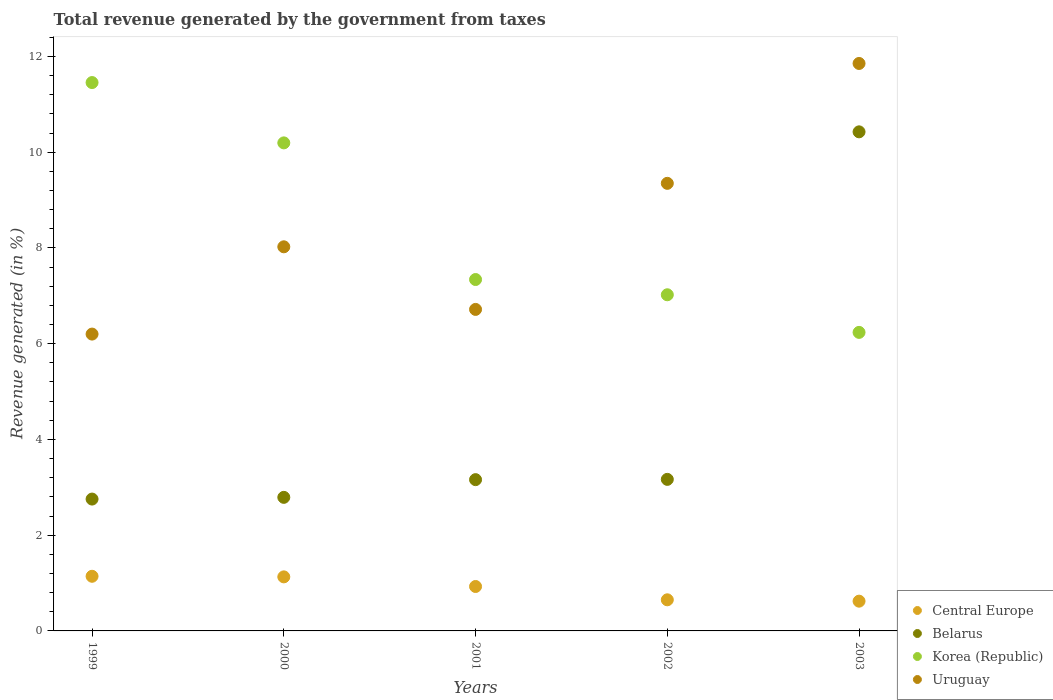How many different coloured dotlines are there?
Offer a terse response. 4. Is the number of dotlines equal to the number of legend labels?
Keep it short and to the point. Yes. What is the total revenue generated in Belarus in 2001?
Offer a terse response. 3.16. Across all years, what is the maximum total revenue generated in Korea (Republic)?
Keep it short and to the point. 11.46. Across all years, what is the minimum total revenue generated in Belarus?
Give a very brief answer. 2.75. In which year was the total revenue generated in Belarus minimum?
Provide a short and direct response. 1999. What is the total total revenue generated in Uruguay in the graph?
Make the answer very short. 42.15. What is the difference between the total revenue generated in Korea (Republic) in 2002 and that in 2003?
Your answer should be very brief. 0.79. What is the difference between the total revenue generated in Belarus in 1999 and the total revenue generated in Central Europe in 2000?
Offer a terse response. 1.63. What is the average total revenue generated in Uruguay per year?
Your answer should be very brief. 8.43. In the year 1999, what is the difference between the total revenue generated in Korea (Republic) and total revenue generated in Central Europe?
Your response must be concise. 10.31. In how many years, is the total revenue generated in Belarus greater than 4 %?
Offer a terse response. 1. What is the ratio of the total revenue generated in Central Europe in 2000 to that in 2002?
Your response must be concise. 1.74. Is the total revenue generated in Uruguay in 2000 less than that in 2001?
Keep it short and to the point. No. Is the difference between the total revenue generated in Korea (Republic) in 2001 and 2002 greater than the difference between the total revenue generated in Central Europe in 2001 and 2002?
Ensure brevity in your answer.  Yes. What is the difference between the highest and the second highest total revenue generated in Korea (Republic)?
Ensure brevity in your answer.  1.26. What is the difference between the highest and the lowest total revenue generated in Korea (Republic)?
Your answer should be very brief. 5.22. In how many years, is the total revenue generated in Belarus greater than the average total revenue generated in Belarus taken over all years?
Offer a terse response. 1. Is it the case that in every year, the sum of the total revenue generated in Central Europe and total revenue generated in Uruguay  is greater than the sum of total revenue generated in Korea (Republic) and total revenue generated in Belarus?
Your answer should be compact. Yes. Is the total revenue generated in Korea (Republic) strictly greater than the total revenue generated in Uruguay over the years?
Your answer should be very brief. No. How many dotlines are there?
Keep it short and to the point. 4. How many years are there in the graph?
Give a very brief answer. 5. What is the difference between two consecutive major ticks on the Y-axis?
Your answer should be very brief. 2. Does the graph contain any zero values?
Offer a terse response. No. How many legend labels are there?
Your answer should be compact. 4. How are the legend labels stacked?
Provide a short and direct response. Vertical. What is the title of the graph?
Your answer should be compact. Total revenue generated by the government from taxes. Does "St. Vincent and the Grenadines" appear as one of the legend labels in the graph?
Give a very brief answer. No. What is the label or title of the X-axis?
Ensure brevity in your answer.  Years. What is the label or title of the Y-axis?
Provide a short and direct response. Revenue generated (in %). What is the Revenue generated (in %) in Central Europe in 1999?
Give a very brief answer. 1.14. What is the Revenue generated (in %) of Belarus in 1999?
Your answer should be compact. 2.75. What is the Revenue generated (in %) in Korea (Republic) in 1999?
Provide a short and direct response. 11.46. What is the Revenue generated (in %) in Uruguay in 1999?
Make the answer very short. 6.2. What is the Revenue generated (in %) of Central Europe in 2000?
Make the answer very short. 1.13. What is the Revenue generated (in %) of Belarus in 2000?
Offer a very short reply. 2.79. What is the Revenue generated (in %) of Korea (Republic) in 2000?
Provide a succinct answer. 10.2. What is the Revenue generated (in %) in Uruguay in 2000?
Provide a succinct answer. 8.02. What is the Revenue generated (in %) of Central Europe in 2001?
Offer a terse response. 0.93. What is the Revenue generated (in %) of Belarus in 2001?
Ensure brevity in your answer.  3.16. What is the Revenue generated (in %) of Korea (Republic) in 2001?
Keep it short and to the point. 7.34. What is the Revenue generated (in %) of Uruguay in 2001?
Provide a succinct answer. 6.72. What is the Revenue generated (in %) of Central Europe in 2002?
Offer a very short reply. 0.65. What is the Revenue generated (in %) in Belarus in 2002?
Your answer should be compact. 3.17. What is the Revenue generated (in %) of Korea (Republic) in 2002?
Provide a short and direct response. 7.02. What is the Revenue generated (in %) in Uruguay in 2002?
Offer a very short reply. 9.35. What is the Revenue generated (in %) of Central Europe in 2003?
Offer a very short reply. 0.62. What is the Revenue generated (in %) in Belarus in 2003?
Your answer should be compact. 10.43. What is the Revenue generated (in %) in Korea (Republic) in 2003?
Offer a terse response. 6.24. What is the Revenue generated (in %) of Uruguay in 2003?
Make the answer very short. 11.85. Across all years, what is the maximum Revenue generated (in %) of Central Europe?
Your answer should be compact. 1.14. Across all years, what is the maximum Revenue generated (in %) of Belarus?
Your answer should be compact. 10.43. Across all years, what is the maximum Revenue generated (in %) in Korea (Republic)?
Keep it short and to the point. 11.46. Across all years, what is the maximum Revenue generated (in %) in Uruguay?
Your answer should be very brief. 11.85. Across all years, what is the minimum Revenue generated (in %) of Central Europe?
Make the answer very short. 0.62. Across all years, what is the minimum Revenue generated (in %) of Belarus?
Offer a very short reply. 2.75. Across all years, what is the minimum Revenue generated (in %) of Korea (Republic)?
Offer a very short reply. 6.24. Across all years, what is the minimum Revenue generated (in %) of Uruguay?
Provide a succinct answer. 6.2. What is the total Revenue generated (in %) in Central Europe in the graph?
Keep it short and to the point. 4.47. What is the total Revenue generated (in %) in Belarus in the graph?
Your answer should be very brief. 22.3. What is the total Revenue generated (in %) in Korea (Republic) in the graph?
Your response must be concise. 42.25. What is the total Revenue generated (in %) in Uruguay in the graph?
Offer a terse response. 42.15. What is the difference between the Revenue generated (in %) in Central Europe in 1999 and that in 2000?
Your answer should be compact. 0.01. What is the difference between the Revenue generated (in %) in Belarus in 1999 and that in 2000?
Offer a very short reply. -0.04. What is the difference between the Revenue generated (in %) of Korea (Republic) in 1999 and that in 2000?
Keep it short and to the point. 1.26. What is the difference between the Revenue generated (in %) of Uruguay in 1999 and that in 2000?
Offer a terse response. -1.82. What is the difference between the Revenue generated (in %) in Central Europe in 1999 and that in 2001?
Keep it short and to the point. 0.21. What is the difference between the Revenue generated (in %) in Belarus in 1999 and that in 2001?
Provide a succinct answer. -0.41. What is the difference between the Revenue generated (in %) in Korea (Republic) in 1999 and that in 2001?
Provide a succinct answer. 4.11. What is the difference between the Revenue generated (in %) of Uruguay in 1999 and that in 2001?
Offer a very short reply. -0.52. What is the difference between the Revenue generated (in %) in Central Europe in 1999 and that in 2002?
Ensure brevity in your answer.  0.49. What is the difference between the Revenue generated (in %) of Belarus in 1999 and that in 2002?
Give a very brief answer. -0.41. What is the difference between the Revenue generated (in %) of Korea (Republic) in 1999 and that in 2002?
Keep it short and to the point. 4.43. What is the difference between the Revenue generated (in %) of Uruguay in 1999 and that in 2002?
Keep it short and to the point. -3.15. What is the difference between the Revenue generated (in %) in Central Europe in 1999 and that in 2003?
Make the answer very short. 0.52. What is the difference between the Revenue generated (in %) of Belarus in 1999 and that in 2003?
Give a very brief answer. -7.67. What is the difference between the Revenue generated (in %) in Korea (Republic) in 1999 and that in 2003?
Provide a short and direct response. 5.22. What is the difference between the Revenue generated (in %) in Uruguay in 1999 and that in 2003?
Your answer should be compact. -5.65. What is the difference between the Revenue generated (in %) of Central Europe in 2000 and that in 2001?
Your answer should be compact. 0.2. What is the difference between the Revenue generated (in %) of Belarus in 2000 and that in 2001?
Provide a short and direct response. -0.37. What is the difference between the Revenue generated (in %) of Korea (Republic) in 2000 and that in 2001?
Ensure brevity in your answer.  2.85. What is the difference between the Revenue generated (in %) of Uruguay in 2000 and that in 2001?
Your response must be concise. 1.31. What is the difference between the Revenue generated (in %) in Central Europe in 2000 and that in 2002?
Ensure brevity in your answer.  0.48. What is the difference between the Revenue generated (in %) in Belarus in 2000 and that in 2002?
Ensure brevity in your answer.  -0.38. What is the difference between the Revenue generated (in %) in Korea (Republic) in 2000 and that in 2002?
Offer a terse response. 3.17. What is the difference between the Revenue generated (in %) of Uruguay in 2000 and that in 2002?
Provide a succinct answer. -1.33. What is the difference between the Revenue generated (in %) of Central Europe in 2000 and that in 2003?
Offer a very short reply. 0.51. What is the difference between the Revenue generated (in %) in Belarus in 2000 and that in 2003?
Your answer should be very brief. -7.64. What is the difference between the Revenue generated (in %) in Korea (Republic) in 2000 and that in 2003?
Your answer should be very brief. 3.96. What is the difference between the Revenue generated (in %) in Uruguay in 2000 and that in 2003?
Offer a terse response. -3.83. What is the difference between the Revenue generated (in %) in Central Europe in 2001 and that in 2002?
Your response must be concise. 0.28. What is the difference between the Revenue generated (in %) in Belarus in 2001 and that in 2002?
Keep it short and to the point. -0.01. What is the difference between the Revenue generated (in %) in Korea (Republic) in 2001 and that in 2002?
Keep it short and to the point. 0.32. What is the difference between the Revenue generated (in %) in Uruguay in 2001 and that in 2002?
Make the answer very short. -2.63. What is the difference between the Revenue generated (in %) in Central Europe in 2001 and that in 2003?
Ensure brevity in your answer.  0.31. What is the difference between the Revenue generated (in %) of Belarus in 2001 and that in 2003?
Your answer should be very brief. -7.27. What is the difference between the Revenue generated (in %) of Korea (Republic) in 2001 and that in 2003?
Keep it short and to the point. 1.1. What is the difference between the Revenue generated (in %) in Uruguay in 2001 and that in 2003?
Your response must be concise. -5.14. What is the difference between the Revenue generated (in %) of Central Europe in 2002 and that in 2003?
Offer a very short reply. 0.03. What is the difference between the Revenue generated (in %) of Belarus in 2002 and that in 2003?
Your answer should be compact. -7.26. What is the difference between the Revenue generated (in %) of Korea (Republic) in 2002 and that in 2003?
Offer a terse response. 0.79. What is the difference between the Revenue generated (in %) in Uruguay in 2002 and that in 2003?
Provide a short and direct response. -2.5. What is the difference between the Revenue generated (in %) in Central Europe in 1999 and the Revenue generated (in %) in Belarus in 2000?
Make the answer very short. -1.65. What is the difference between the Revenue generated (in %) in Central Europe in 1999 and the Revenue generated (in %) in Korea (Republic) in 2000?
Your response must be concise. -9.05. What is the difference between the Revenue generated (in %) in Central Europe in 1999 and the Revenue generated (in %) in Uruguay in 2000?
Provide a short and direct response. -6.88. What is the difference between the Revenue generated (in %) in Belarus in 1999 and the Revenue generated (in %) in Korea (Republic) in 2000?
Provide a short and direct response. -7.44. What is the difference between the Revenue generated (in %) of Belarus in 1999 and the Revenue generated (in %) of Uruguay in 2000?
Your response must be concise. -5.27. What is the difference between the Revenue generated (in %) in Korea (Republic) in 1999 and the Revenue generated (in %) in Uruguay in 2000?
Make the answer very short. 3.43. What is the difference between the Revenue generated (in %) in Central Europe in 1999 and the Revenue generated (in %) in Belarus in 2001?
Provide a short and direct response. -2.02. What is the difference between the Revenue generated (in %) in Central Europe in 1999 and the Revenue generated (in %) in Korea (Republic) in 2001?
Give a very brief answer. -6.2. What is the difference between the Revenue generated (in %) in Central Europe in 1999 and the Revenue generated (in %) in Uruguay in 2001?
Offer a very short reply. -5.57. What is the difference between the Revenue generated (in %) in Belarus in 1999 and the Revenue generated (in %) in Korea (Republic) in 2001?
Provide a succinct answer. -4.59. What is the difference between the Revenue generated (in %) of Belarus in 1999 and the Revenue generated (in %) of Uruguay in 2001?
Keep it short and to the point. -3.96. What is the difference between the Revenue generated (in %) of Korea (Republic) in 1999 and the Revenue generated (in %) of Uruguay in 2001?
Provide a short and direct response. 4.74. What is the difference between the Revenue generated (in %) of Central Europe in 1999 and the Revenue generated (in %) of Belarus in 2002?
Your answer should be very brief. -2.02. What is the difference between the Revenue generated (in %) in Central Europe in 1999 and the Revenue generated (in %) in Korea (Republic) in 2002?
Ensure brevity in your answer.  -5.88. What is the difference between the Revenue generated (in %) of Central Europe in 1999 and the Revenue generated (in %) of Uruguay in 2002?
Ensure brevity in your answer.  -8.21. What is the difference between the Revenue generated (in %) of Belarus in 1999 and the Revenue generated (in %) of Korea (Republic) in 2002?
Keep it short and to the point. -4.27. What is the difference between the Revenue generated (in %) in Belarus in 1999 and the Revenue generated (in %) in Uruguay in 2002?
Keep it short and to the point. -6.6. What is the difference between the Revenue generated (in %) in Korea (Republic) in 1999 and the Revenue generated (in %) in Uruguay in 2002?
Your answer should be compact. 2.11. What is the difference between the Revenue generated (in %) in Central Europe in 1999 and the Revenue generated (in %) in Belarus in 2003?
Ensure brevity in your answer.  -9.28. What is the difference between the Revenue generated (in %) in Central Europe in 1999 and the Revenue generated (in %) in Korea (Republic) in 2003?
Give a very brief answer. -5.09. What is the difference between the Revenue generated (in %) of Central Europe in 1999 and the Revenue generated (in %) of Uruguay in 2003?
Ensure brevity in your answer.  -10.71. What is the difference between the Revenue generated (in %) in Belarus in 1999 and the Revenue generated (in %) in Korea (Republic) in 2003?
Offer a very short reply. -3.48. What is the difference between the Revenue generated (in %) of Belarus in 1999 and the Revenue generated (in %) of Uruguay in 2003?
Your answer should be very brief. -9.1. What is the difference between the Revenue generated (in %) of Korea (Republic) in 1999 and the Revenue generated (in %) of Uruguay in 2003?
Offer a very short reply. -0.4. What is the difference between the Revenue generated (in %) of Central Europe in 2000 and the Revenue generated (in %) of Belarus in 2001?
Offer a terse response. -2.03. What is the difference between the Revenue generated (in %) of Central Europe in 2000 and the Revenue generated (in %) of Korea (Republic) in 2001?
Make the answer very short. -6.21. What is the difference between the Revenue generated (in %) in Central Europe in 2000 and the Revenue generated (in %) in Uruguay in 2001?
Your answer should be compact. -5.59. What is the difference between the Revenue generated (in %) in Belarus in 2000 and the Revenue generated (in %) in Korea (Republic) in 2001?
Provide a short and direct response. -4.55. What is the difference between the Revenue generated (in %) of Belarus in 2000 and the Revenue generated (in %) of Uruguay in 2001?
Your answer should be compact. -3.93. What is the difference between the Revenue generated (in %) of Korea (Republic) in 2000 and the Revenue generated (in %) of Uruguay in 2001?
Your response must be concise. 3.48. What is the difference between the Revenue generated (in %) in Central Europe in 2000 and the Revenue generated (in %) in Belarus in 2002?
Offer a terse response. -2.04. What is the difference between the Revenue generated (in %) of Central Europe in 2000 and the Revenue generated (in %) of Korea (Republic) in 2002?
Provide a short and direct response. -5.89. What is the difference between the Revenue generated (in %) of Central Europe in 2000 and the Revenue generated (in %) of Uruguay in 2002?
Give a very brief answer. -8.22. What is the difference between the Revenue generated (in %) of Belarus in 2000 and the Revenue generated (in %) of Korea (Republic) in 2002?
Offer a terse response. -4.23. What is the difference between the Revenue generated (in %) in Belarus in 2000 and the Revenue generated (in %) in Uruguay in 2002?
Ensure brevity in your answer.  -6.56. What is the difference between the Revenue generated (in %) in Korea (Republic) in 2000 and the Revenue generated (in %) in Uruguay in 2002?
Offer a terse response. 0.85. What is the difference between the Revenue generated (in %) of Central Europe in 2000 and the Revenue generated (in %) of Belarus in 2003?
Make the answer very short. -9.3. What is the difference between the Revenue generated (in %) of Central Europe in 2000 and the Revenue generated (in %) of Korea (Republic) in 2003?
Your response must be concise. -5.11. What is the difference between the Revenue generated (in %) of Central Europe in 2000 and the Revenue generated (in %) of Uruguay in 2003?
Make the answer very short. -10.73. What is the difference between the Revenue generated (in %) of Belarus in 2000 and the Revenue generated (in %) of Korea (Republic) in 2003?
Offer a terse response. -3.45. What is the difference between the Revenue generated (in %) in Belarus in 2000 and the Revenue generated (in %) in Uruguay in 2003?
Your answer should be compact. -9.06. What is the difference between the Revenue generated (in %) of Korea (Republic) in 2000 and the Revenue generated (in %) of Uruguay in 2003?
Your answer should be very brief. -1.66. What is the difference between the Revenue generated (in %) of Central Europe in 2001 and the Revenue generated (in %) of Belarus in 2002?
Give a very brief answer. -2.24. What is the difference between the Revenue generated (in %) in Central Europe in 2001 and the Revenue generated (in %) in Korea (Republic) in 2002?
Give a very brief answer. -6.09. What is the difference between the Revenue generated (in %) in Central Europe in 2001 and the Revenue generated (in %) in Uruguay in 2002?
Your response must be concise. -8.42. What is the difference between the Revenue generated (in %) in Belarus in 2001 and the Revenue generated (in %) in Korea (Republic) in 2002?
Provide a short and direct response. -3.86. What is the difference between the Revenue generated (in %) of Belarus in 2001 and the Revenue generated (in %) of Uruguay in 2002?
Offer a very short reply. -6.19. What is the difference between the Revenue generated (in %) of Korea (Republic) in 2001 and the Revenue generated (in %) of Uruguay in 2002?
Make the answer very short. -2.01. What is the difference between the Revenue generated (in %) in Central Europe in 2001 and the Revenue generated (in %) in Belarus in 2003?
Offer a very short reply. -9.5. What is the difference between the Revenue generated (in %) of Central Europe in 2001 and the Revenue generated (in %) of Korea (Republic) in 2003?
Your response must be concise. -5.31. What is the difference between the Revenue generated (in %) of Central Europe in 2001 and the Revenue generated (in %) of Uruguay in 2003?
Provide a short and direct response. -10.93. What is the difference between the Revenue generated (in %) in Belarus in 2001 and the Revenue generated (in %) in Korea (Republic) in 2003?
Your response must be concise. -3.08. What is the difference between the Revenue generated (in %) in Belarus in 2001 and the Revenue generated (in %) in Uruguay in 2003?
Make the answer very short. -8.69. What is the difference between the Revenue generated (in %) of Korea (Republic) in 2001 and the Revenue generated (in %) of Uruguay in 2003?
Provide a short and direct response. -4.51. What is the difference between the Revenue generated (in %) in Central Europe in 2002 and the Revenue generated (in %) in Belarus in 2003?
Your answer should be compact. -9.78. What is the difference between the Revenue generated (in %) in Central Europe in 2002 and the Revenue generated (in %) in Korea (Republic) in 2003?
Provide a short and direct response. -5.59. What is the difference between the Revenue generated (in %) in Central Europe in 2002 and the Revenue generated (in %) in Uruguay in 2003?
Provide a succinct answer. -11.2. What is the difference between the Revenue generated (in %) of Belarus in 2002 and the Revenue generated (in %) of Korea (Republic) in 2003?
Keep it short and to the point. -3.07. What is the difference between the Revenue generated (in %) in Belarus in 2002 and the Revenue generated (in %) in Uruguay in 2003?
Offer a very short reply. -8.69. What is the difference between the Revenue generated (in %) of Korea (Republic) in 2002 and the Revenue generated (in %) of Uruguay in 2003?
Give a very brief answer. -4.83. What is the average Revenue generated (in %) of Central Europe per year?
Offer a very short reply. 0.89. What is the average Revenue generated (in %) of Belarus per year?
Give a very brief answer. 4.46. What is the average Revenue generated (in %) in Korea (Republic) per year?
Give a very brief answer. 8.45. What is the average Revenue generated (in %) of Uruguay per year?
Offer a terse response. 8.43. In the year 1999, what is the difference between the Revenue generated (in %) of Central Europe and Revenue generated (in %) of Belarus?
Give a very brief answer. -1.61. In the year 1999, what is the difference between the Revenue generated (in %) in Central Europe and Revenue generated (in %) in Korea (Republic)?
Keep it short and to the point. -10.31. In the year 1999, what is the difference between the Revenue generated (in %) of Central Europe and Revenue generated (in %) of Uruguay?
Provide a succinct answer. -5.06. In the year 1999, what is the difference between the Revenue generated (in %) of Belarus and Revenue generated (in %) of Korea (Republic)?
Make the answer very short. -8.7. In the year 1999, what is the difference between the Revenue generated (in %) in Belarus and Revenue generated (in %) in Uruguay?
Make the answer very short. -3.45. In the year 1999, what is the difference between the Revenue generated (in %) in Korea (Republic) and Revenue generated (in %) in Uruguay?
Your response must be concise. 5.25. In the year 2000, what is the difference between the Revenue generated (in %) of Central Europe and Revenue generated (in %) of Belarus?
Keep it short and to the point. -1.66. In the year 2000, what is the difference between the Revenue generated (in %) of Central Europe and Revenue generated (in %) of Korea (Republic)?
Keep it short and to the point. -9.07. In the year 2000, what is the difference between the Revenue generated (in %) in Central Europe and Revenue generated (in %) in Uruguay?
Offer a very short reply. -6.9. In the year 2000, what is the difference between the Revenue generated (in %) of Belarus and Revenue generated (in %) of Korea (Republic)?
Provide a succinct answer. -7.4. In the year 2000, what is the difference between the Revenue generated (in %) in Belarus and Revenue generated (in %) in Uruguay?
Give a very brief answer. -5.23. In the year 2000, what is the difference between the Revenue generated (in %) in Korea (Republic) and Revenue generated (in %) in Uruguay?
Offer a very short reply. 2.17. In the year 2001, what is the difference between the Revenue generated (in %) of Central Europe and Revenue generated (in %) of Belarus?
Provide a succinct answer. -2.23. In the year 2001, what is the difference between the Revenue generated (in %) of Central Europe and Revenue generated (in %) of Korea (Republic)?
Offer a terse response. -6.41. In the year 2001, what is the difference between the Revenue generated (in %) in Central Europe and Revenue generated (in %) in Uruguay?
Provide a succinct answer. -5.79. In the year 2001, what is the difference between the Revenue generated (in %) of Belarus and Revenue generated (in %) of Korea (Republic)?
Your answer should be very brief. -4.18. In the year 2001, what is the difference between the Revenue generated (in %) in Belarus and Revenue generated (in %) in Uruguay?
Offer a terse response. -3.56. In the year 2001, what is the difference between the Revenue generated (in %) of Korea (Republic) and Revenue generated (in %) of Uruguay?
Ensure brevity in your answer.  0.62. In the year 2002, what is the difference between the Revenue generated (in %) in Central Europe and Revenue generated (in %) in Belarus?
Offer a very short reply. -2.52. In the year 2002, what is the difference between the Revenue generated (in %) in Central Europe and Revenue generated (in %) in Korea (Republic)?
Keep it short and to the point. -6.37. In the year 2002, what is the difference between the Revenue generated (in %) of Central Europe and Revenue generated (in %) of Uruguay?
Offer a terse response. -8.7. In the year 2002, what is the difference between the Revenue generated (in %) of Belarus and Revenue generated (in %) of Korea (Republic)?
Ensure brevity in your answer.  -3.86. In the year 2002, what is the difference between the Revenue generated (in %) in Belarus and Revenue generated (in %) in Uruguay?
Your answer should be very brief. -6.18. In the year 2002, what is the difference between the Revenue generated (in %) in Korea (Republic) and Revenue generated (in %) in Uruguay?
Your answer should be very brief. -2.33. In the year 2003, what is the difference between the Revenue generated (in %) in Central Europe and Revenue generated (in %) in Belarus?
Ensure brevity in your answer.  -9.8. In the year 2003, what is the difference between the Revenue generated (in %) in Central Europe and Revenue generated (in %) in Korea (Republic)?
Offer a terse response. -5.61. In the year 2003, what is the difference between the Revenue generated (in %) of Central Europe and Revenue generated (in %) of Uruguay?
Keep it short and to the point. -11.23. In the year 2003, what is the difference between the Revenue generated (in %) of Belarus and Revenue generated (in %) of Korea (Republic)?
Your answer should be compact. 4.19. In the year 2003, what is the difference between the Revenue generated (in %) in Belarus and Revenue generated (in %) in Uruguay?
Your answer should be compact. -1.43. In the year 2003, what is the difference between the Revenue generated (in %) of Korea (Republic) and Revenue generated (in %) of Uruguay?
Give a very brief answer. -5.62. What is the ratio of the Revenue generated (in %) in Central Europe in 1999 to that in 2000?
Keep it short and to the point. 1.01. What is the ratio of the Revenue generated (in %) in Belarus in 1999 to that in 2000?
Make the answer very short. 0.99. What is the ratio of the Revenue generated (in %) of Korea (Republic) in 1999 to that in 2000?
Offer a very short reply. 1.12. What is the ratio of the Revenue generated (in %) of Uruguay in 1999 to that in 2000?
Provide a succinct answer. 0.77. What is the ratio of the Revenue generated (in %) of Central Europe in 1999 to that in 2001?
Offer a terse response. 1.23. What is the ratio of the Revenue generated (in %) of Belarus in 1999 to that in 2001?
Your answer should be very brief. 0.87. What is the ratio of the Revenue generated (in %) in Korea (Republic) in 1999 to that in 2001?
Give a very brief answer. 1.56. What is the ratio of the Revenue generated (in %) in Uruguay in 1999 to that in 2001?
Keep it short and to the point. 0.92. What is the ratio of the Revenue generated (in %) of Central Europe in 1999 to that in 2002?
Provide a short and direct response. 1.76. What is the ratio of the Revenue generated (in %) of Belarus in 1999 to that in 2002?
Ensure brevity in your answer.  0.87. What is the ratio of the Revenue generated (in %) in Korea (Republic) in 1999 to that in 2002?
Provide a succinct answer. 1.63. What is the ratio of the Revenue generated (in %) in Uruguay in 1999 to that in 2002?
Ensure brevity in your answer.  0.66. What is the ratio of the Revenue generated (in %) of Central Europe in 1999 to that in 2003?
Provide a short and direct response. 1.84. What is the ratio of the Revenue generated (in %) of Belarus in 1999 to that in 2003?
Make the answer very short. 0.26. What is the ratio of the Revenue generated (in %) of Korea (Republic) in 1999 to that in 2003?
Offer a terse response. 1.84. What is the ratio of the Revenue generated (in %) in Uruguay in 1999 to that in 2003?
Your response must be concise. 0.52. What is the ratio of the Revenue generated (in %) in Central Europe in 2000 to that in 2001?
Make the answer very short. 1.22. What is the ratio of the Revenue generated (in %) in Belarus in 2000 to that in 2001?
Ensure brevity in your answer.  0.88. What is the ratio of the Revenue generated (in %) in Korea (Republic) in 2000 to that in 2001?
Provide a short and direct response. 1.39. What is the ratio of the Revenue generated (in %) of Uruguay in 2000 to that in 2001?
Your answer should be compact. 1.19. What is the ratio of the Revenue generated (in %) of Central Europe in 2000 to that in 2002?
Your response must be concise. 1.74. What is the ratio of the Revenue generated (in %) in Belarus in 2000 to that in 2002?
Give a very brief answer. 0.88. What is the ratio of the Revenue generated (in %) of Korea (Republic) in 2000 to that in 2002?
Your answer should be compact. 1.45. What is the ratio of the Revenue generated (in %) of Uruguay in 2000 to that in 2002?
Keep it short and to the point. 0.86. What is the ratio of the Revenue generated (in %) of Central Europe in 2000 to that in 2003?
Offer a terse response. 1.82. What is the ratio of the Revenue generated (in %) of Belarus in 2000 to that in 2003?
Give a very brief answer. 0.27. What is the ratio of the Revenue generated (in %) in Korea (Republic) in 2000 to that in 2003?
Make the answer very short. 1.63. What is the ratio of the Revenue generated (in %) in Uruguay in 2000 to that in 2003?
Give a very brief answer. 0.68. What is the ratio of the Revenue generated (in %) in Central Europe in 2001 to that in 2002?
Make the answer very short. 1.43. What is the ratio of the Revenue generated (in %) in Korea (Republic) in 2001 to that in 2002?
Give a very brief answer. 1.05. What is the ratio of the Revenue generated (in %) in Uruguay in 2001 to that in 2002?
Offer a very short reply. 0.72. What is the ratio of the Revenue generated (in %) in Central Europe in 2001 to that in 2003?
Keep it short and to the point. 1.49. What is the ratio of the Revenue generated (in %) in Belarus in 2001 to that in 2003?
Your answer should be compact. 0.3. What is the ratio of the Revenue generated (in %) of Korea (Republic) in 2001 to that in 2003?
Your answer should be compact. 1.18. What is the ratio of the Revenue generated (in %) in Uruguay in 2001 to that in 2003?
Offer a terse response. 0.57. What is the ratio of the Revenue generated (in %) in Central Europe in 2002 to that in 2003?
Your answer should be very brief. 1.05. What is the ratio of the Revenue generated (in %) of Belarus in 2002 to that in 2003?
Offer a very short reply. 0.3. What is the ratio of the Revenue generated (in %) of Korea (Republic) in 2002 to that in 2003?
Provide a short and direct response. 1.13. What is the ratio of the Revenue generated (in %) of Uruguay in 2002 to that in 2003?
Ensure brevity in your answer.  0.79. What is the difference between the highest and the second highest Revenue generated (in %) of Central Europe?
Your answer should be compact. 0.01. What is the difference between the highest and the second highest Revenue generated (in %) in Belarus?
Give a very brief answer. 7.26. What is the difference between the highest and the second highest Revenue generated (in %) in Korea (Republic)?
Your answer should be very brief. 1.26. What is the difference between the highest and the second highest Revenue generated (in %) of Uruguay?
Offer a terse response. 2.5. What is the difference between the highest and the lowest Revenue generated (in %) of Central Europe?
Offer a terse response. 0.52. What is the difference between the highest and the lowest Revenue generated (in %) in Belarus?
Keep it short and to the point. 7.67. What is the difference between the highest and the lowest Revenue generated (in %) in Korea (Republic)?
Keep it short and to the point. 5.22. What is the difference between the highest and the lowest Revenue generated (in %) of Uruguay?
Offer a terse response. 5.65. 